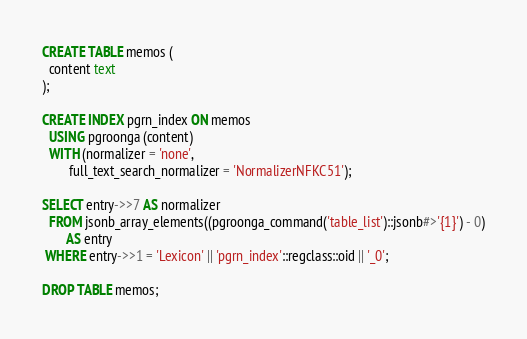Convert code to text. <code><loc_0><loc_0><loc_500><loc_500><_SQL_>CREATE TABLE memos (
  content text
);

CREATE INDEX pgrn_index ON memos
  USING pgroonga (content)
  WITH (normalizer = 'none',
        full_text_search_normalizer = 'NormalizerNFKC51');

SELECT entry->>7 AS normalizer
  FROM jsonb_array_elements((pgroonga_command('table_list')::jsonb#>'{1}') - 0)
       AS entry
 WHERE entry->>1 = 'Lexicon' || 'pgrn_index'::regclass::oid || '_0';

DROP TABLE memos;
</code> 